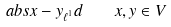<formula> <loc_0><loc_0><loc_500><loc_500>\ a b s { x - y } _ { \ell ^ { 1 } } d \quad x , y \in V</formula> 